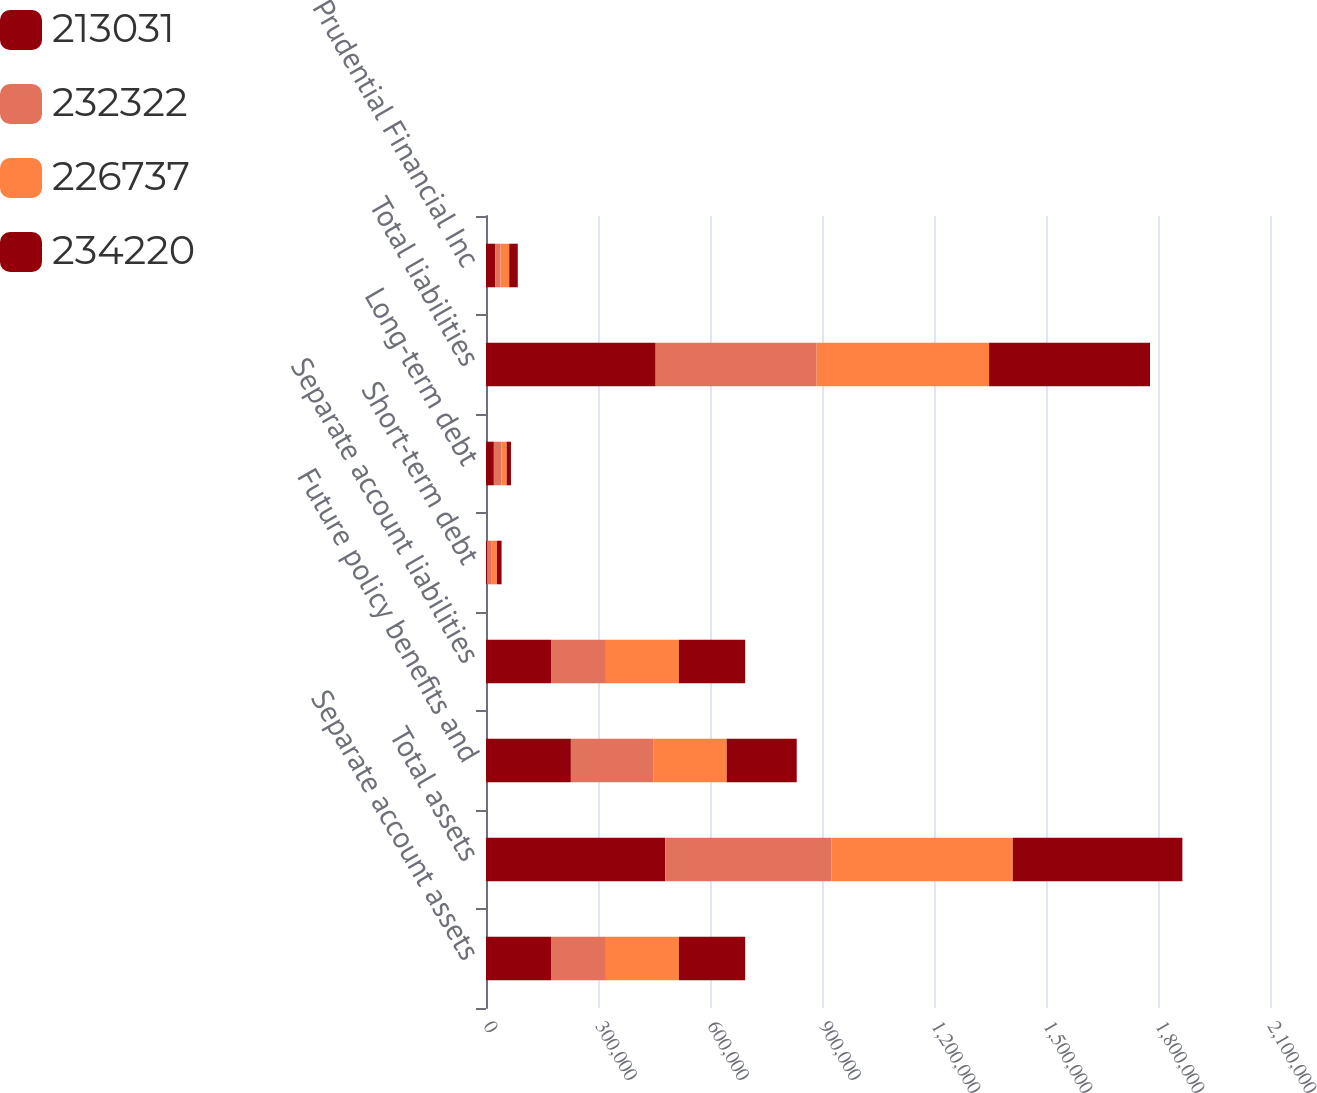Convert chart to OTSL. <chart><loc_0><loc_0><loc_500><loc_500><stacked_bar_chart><ecel><fcel>Separate account assets<fcel>Total assets<fcel>Future policy benefits and<fcel>Separate account liabilities<fcel>Short-term debt<fcel>Long-term debt<fcel>Total liabilities<fcel>Prudential Financial Inc<nl><fcel>213031<fcel>174074<fcel>480203<fcel>227373<fcel>174074<fcel>3122<fcel>21037<fcel>454474<fcel>25195<nl><fcel>232322<fcel>147095<fcel>445011<fcel>221564<fcel>147095<fcel>10535<fcel>20290<fcel>431225<fcel>13435<nl><fcel>226737<fcel>195583<fcel>485813<fcel>195731<fcel>195583<fcel>15566<fcel>14101<fcel>461890<fcel>23514<nl><fcel>234220<fcel>177463<fcel>454266<fcel>187652<fcel>177463<fcel>12472<fcel>11423<fcel>431005<fcel>22932<nl></chart> 